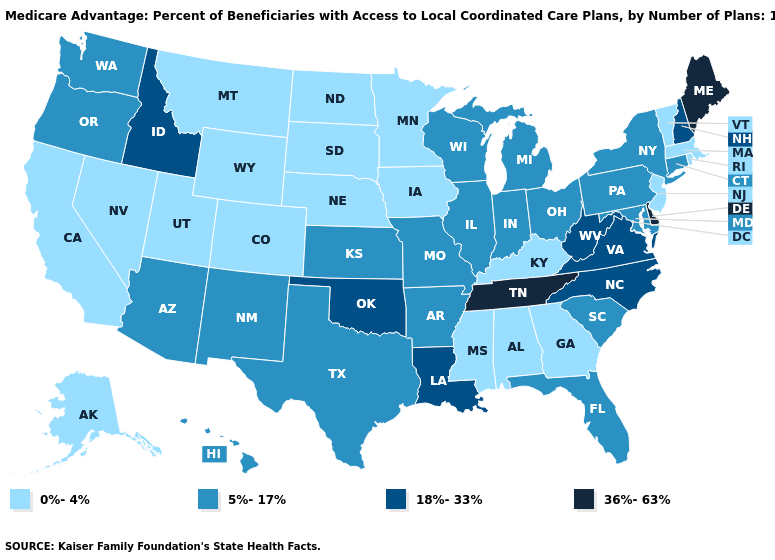Name the states that have a value in the range 36%-63%?
Concise answer only. Delaware, Maine, Tennessee. Does Louisiana have the lowest value in the USA?
Quick response, please. No. How many symbols are there in the legend?
Quick response, please. 4. What is the value of Oregon?
Short answer required. 5%-17%. What is the highest value in the USA?
Give a very brief answer. 36%-63%. Does Wisconsin have the lowest value in the MidWest?
Short answer required. No. Does West Virginia have the same value as Kansas?
Keep it brief. No. Among the states that border Montana , does Idaho have the highest value?
Write a very short answer. Yes. Does the map have missing data?
Answer briefly. No. Name the states that have a value in the range 0%-4%?
Give a very brief answer. Alaska, Alabama, California, Colorado, Georgia, Iowa, Kentucky, Massachusetts, Minnesota, Mississippi, Montana, North Dakota, Nebraska, New Jersey, Nevada, Rhode Island, South Dakota, Utah, Vermont, Wyoming. What is the value of Arkansas?
Answer briefly. 5%-17%. What is the highest value in the West ?
Keep it brief. 18%-33%. What is the lowest value in the USA?
Write a very short answer. 0%-4%. Does Indiana have the lowest value in the MidWest?
Answer briefly. No. What is the value of North Dakota?
Quick response, please. 0%-4%. 